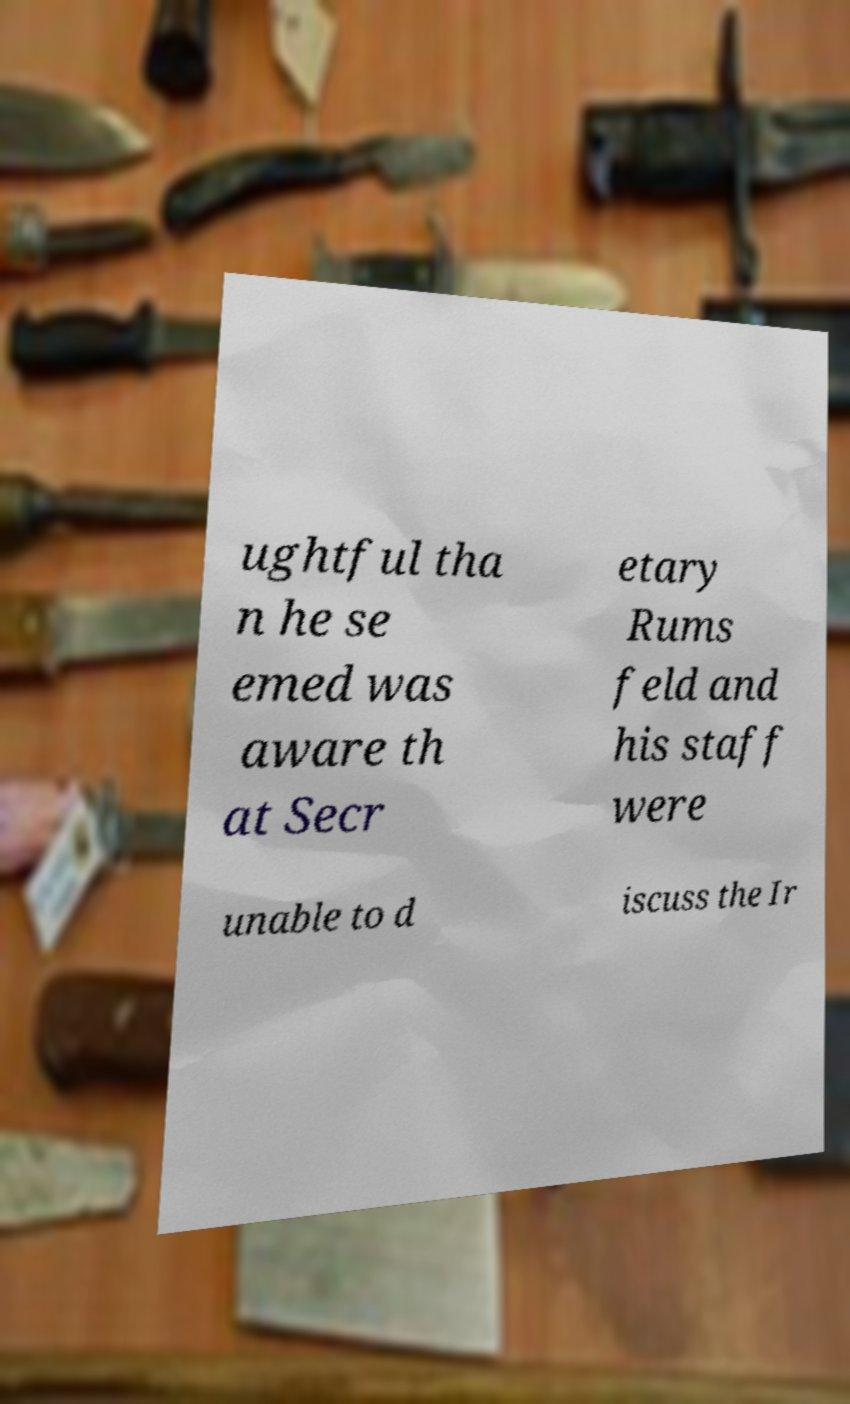Can you read and provide the text displayed in the image?This photo seems to have some interesting text. Can you extract and type it out for me? ughtful tha n he se emed was aware th at Secr etary Rums feld and his staff were unable to d iscuss the Ir 